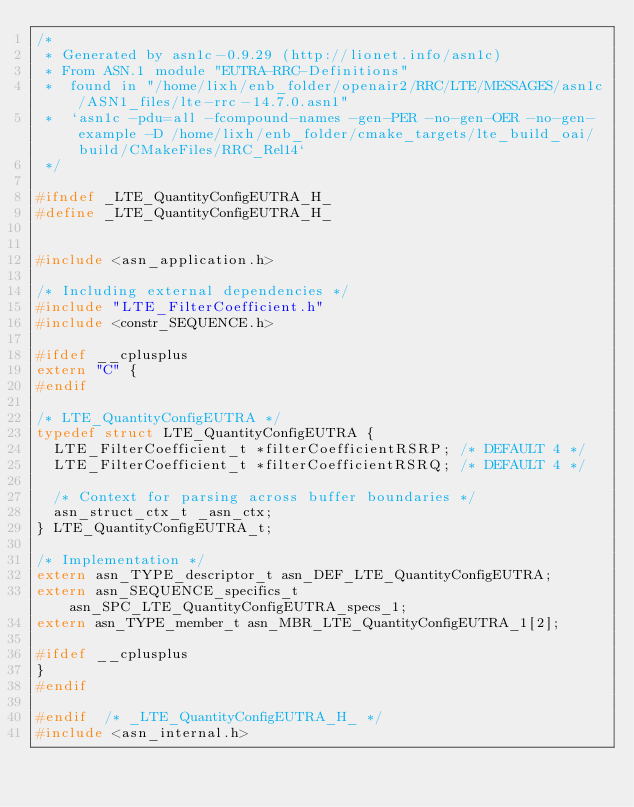Convert code to text. <code><loc_0><loc_0><loc_500><loc_500><_C_>/*
 * Generated by asn1c-0.9.29 (http://lionet.info/asn1c)
 * From ASN.1 module "EUTRA-RRC-Definitions"
 * 	found in "/home/lixh/enb_folder/openair2/RRC/LTE/MESSAGES/asn1c/ASN1_files/lte-rrc-14.7.0.asn1"
 * 	`asn1c -pdu=all -fcompound-names -gen-PER -no-gen-OER -no-gen-example -D /home/lixh/enb_folder/cmake_targets/lte_build_oai/build/CMakeFiles/RRC_Rel14`
 */

#ifndef	_LTE_QuantityConfigEUTRA_H_
#define	_LTE_QuantityConfigEUTRA_H_


#include <asn_application.h>

/* Including external dependencies */
#include "LTE_FilterCoefficient.h"
#include <constr_SEQUENCE.h>

#ifdef __cplusplus
extern "C" {
#endif

/* LTE_QuantityConfigEUTRA */
typedef struct LTE_QuantityConfigEUTRA {
	LTE_FilterCoefficient_t	*filterCoefficientRSRP;	/* DEFAULT 4 */
	LTE_FilterCoefficient_t	*filterCoefficientRSRQ;	/* DEFAULT 4 */
	
	/* Context for parsing across buffer boundaries */
	asn_struct_ctx_t _asn_ctx;
} LTE_QuantityConfigEUTRA_t;

/* Implementation */
extern asn_TYPE_descriptor_t asn_DEF_LTE_QuantityConfigEUTRA;
extern asn_SEQUENCE_specifics_t asn_SPC_LTE_QuantityConfigEUTRA_specs_1;
extern asn_TYPE_member_t asn_MBR_LTE_QuantityConfigEUTRA_1[2];

#ifdef __cplusplus
}
#endif

#endif	/* _LTE_QuantityConfigEUTRA_H_ */
#include <asn_internal.h>
</code> 